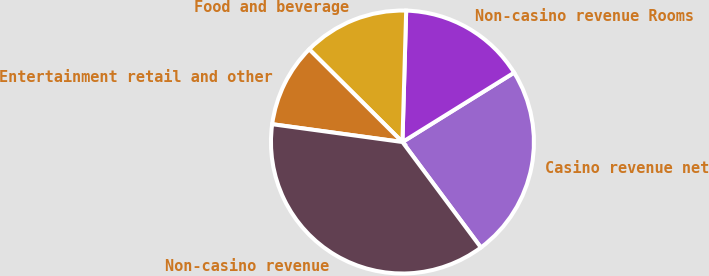<chart> <loc_0><loc_0><loc_500><loc_500><pie_chart><fcel>Casino revenue net<fcel>Non-casino revenue Rooms<fcel>Food and beverage<fcel>Entertainment retail and other<fcel>Non-casino revenue<nl><fcel>23.67%<fcel>15.7%<fcel>13.0%<fcel>10.29%<fcel>37.35%<nl></chart> 